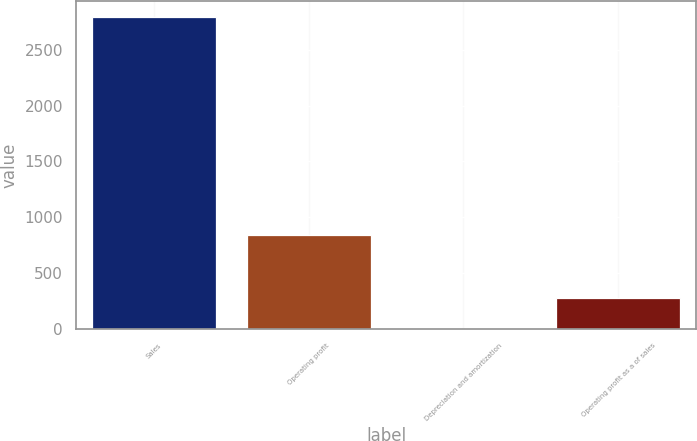<chart> <loc_0><loc_0><loc_500><loc_500><bar_chart><fcel>Sales<fcel>Operating profit<fcel>Depreciation and amortization<fcel>Operating profit as a of sales<nl><fcel>2794.9<fcel>840.01<fcel>2.2<fcel>281.47<nl></chart> 